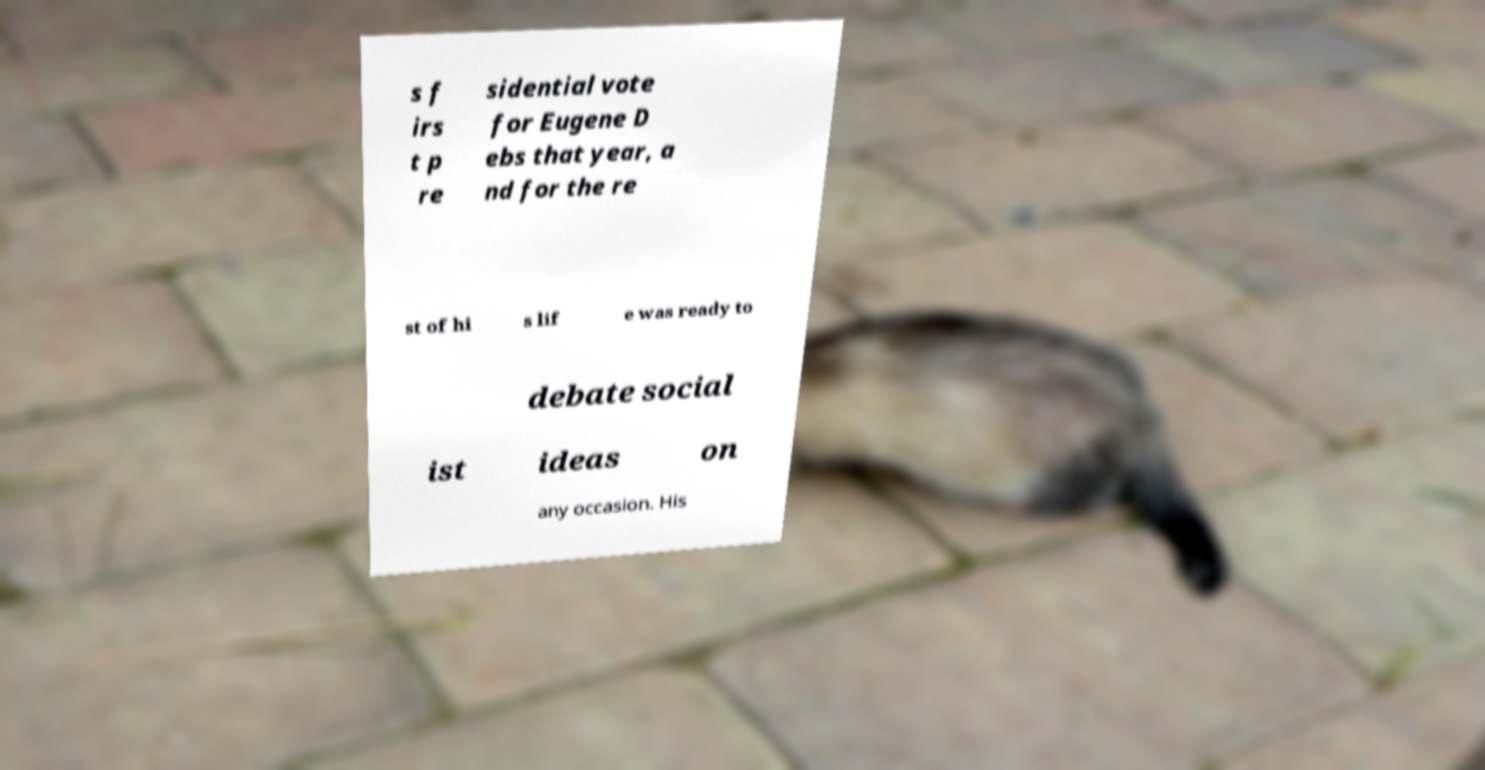Could you assist in decoding the text presented in this image and type it out clearly? s f irs t p re sidential vote for Eugene D ebs that year, a nd for the re st of hi s lif e was ready to debate social ist ideas on any occasion. His 